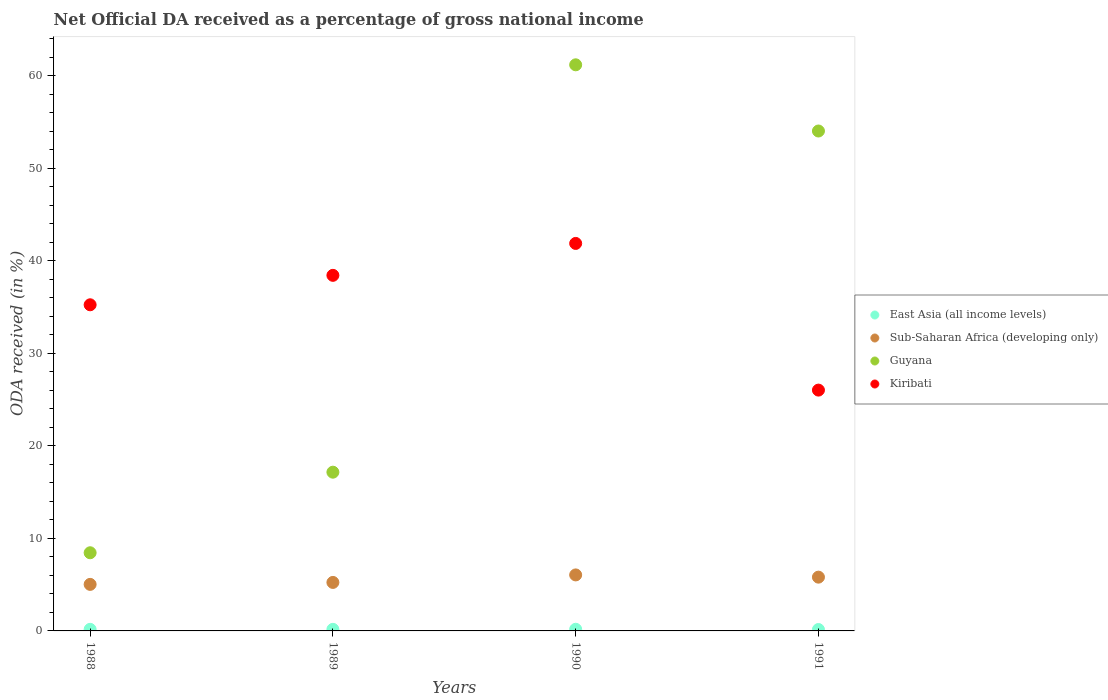Is the number of dotlines equal to the number of legend labels?
Make the answer very short. Yes. What is the net official DA received in Guyana in 1990?
Your answer should be compact. 61.17. Across all years, what is the maximum net official DA received in Guyana?
Your response must be concise. 61.17. Across all years, what is the minimum net official DA received in Kiribati?
Provide a short and direct response. 26.02. What is the total net official DA received in Guyana in the graph?
Your answer should be compact. 140.79. What is the difference between the net official DA received in Guyana in 1989 and that in 1990?
Provide a succinct answer. -44.02. What is the difference between the net official DA received in Guyana in 1991 and the net official DA received in Sub-Saharan Africa (developing only) in 1989?
Make the answer very short. 48.78. What is the average net official DA received in Guyana per year?
Give a very brief answer. 35.2. In the year 1989, what is the difference between the net official DA received in Sub-Saharan Africa (developing only) and net official DA received in Guyana?
Offer a very short reply. -11.91. What is the ratio of the net official DA received in Sub-Saharan Africa (developing only) in 1988 to that in 1991?
Keep it short and to the point. 0.87. Is the net official DA received in Guyana in 1989 less than that in 1991?
Your answer should be very brief. Yes. What is the difference between the highest and the second highest net official DA received in Sub-Saharan Africa (developing only)?
Your answer should be compact. 0.24. What is the difference between the highest and the lowest net official DA received in Kiribati?
Your answer should be very brief. 15.85. Is the sum of the net official DA received in Guyana in 1988 and 1991 greater than the maximum net official DA received in East Asia (all income levels) across all years?
Make the answer very short. Yes. Is it the case that in every year, the sum of the net official DA received in Sub-Saharan Africa (developing only) and net official DA received in Kiribati  is greater than the sum of net official DA received in East Asia (all income levels) and net official DA received in Guyana?
Make the answer very short. No. Is it the case that in every year, the sum of the net official DA received in Guyana and net official DA received in East Asia (all income levels)  is greater than the net official DA received in Sub-Saharan Africa (developing only)?
Provide a short and direct response. Yes. Is the net official DA received in East Asia (all income levels) strictly greater than the net official DA received in Sub-Saharan Africa (developing only) over the years?
Make the answer very short. No. Is the net official DA received in East Asia (all income levels) strictly less than the net official DA received in Guyana over the years?
Your response must be concise. Yes. How many years are there in the graph?
Your answer should be compact. 4. Does the graph contain grids?
Ensure brevity in your answer.  No. Where does the legend appear in the graph?
Provide a succinct answer. Center right. What is the title of the graph?
Offer a very short reply. Net Official DA received as a percentage of gross national income. What is the label or title of the X-axis?
Your response must be concise. Years. What is the label or title of the Y-axis?
Ensure brevity in your answer.  ODA received (in %). What is the ODA received (in %) in East Asia (all income levels) in 1988?
Your response must be concise. 0.17. What is the ODA received (in %) of Sub-Saharan Africa (developing only) in 1988?
Keep it short and to the point. 5.03. What is the ODA received (in %) in Guyana in 1988?
Make the answer very short. 8.45. What is the ODA received (in %) of Kiribati in 1988?
Offer a very short reply. 35.24. What is the ODA received (in %) of East Asia (all income levels) in 1989?
Give a very brief answer. 0.17. What is the ODA received (in %) in Sub-Saharan Africa (developing only) in 1989?
Your answer should be compact. 5.24. What is the ODA received (in %) of Guyana in 1989?
Offer a terse response. 17.15. What is the ODA received (in %) in Kiribati in 1989?
Give a very brief answer. 38.42. What is the ODA received (in %) in East Asia (all income levels) in 1990?
Offer a very short reply. 0.18. What is the ODA received (in %) in Sub-Saharan Africa (developing only) in 1990?
Provide a short and direct response. 6.05. What is the ODA received (in %) in Guyana in 1990?
Ensure brevity in your answer.  61.17. What is the ODA received (in %) of Kiribati in 1990?
Provide a succinct answer. 41.87. What is the ODA received (in %) in East Asia (all income levels) in 1991?
Your answer should be compact. 0.15. What is the ODA received (in %) of Sub-Saharan Africa (developing only) in 1991?
Provide a short and direct response. 5.81. What is the ODA received (in %) in Guyana in 1991?
Keep it short and to the point. 54.02. What is the ODA received (in %) in Kiribati in 1991?
Keep it short and to the point. 26.02. Across all years, what is the maximum ODA received (in %) in East Asia (all income levels)?
Give a very brief answer. 0.18. Across all years, what is the maximum ODA received (in %) in Sub-Saharan Africa (developing only)?
Provide a short and direct response. 6.05. Across all years, what is the maximum ODA received (in %) of Guyana?
Keep it short and to the point. 61.17. Across all years, what is the maximum ODA received (in %) in Kiribati?
Make the answer very short. 41.87. Across all years, what is the minimum ODA received (in %) in East Asia (all income levels)?
Give a very brief answer. 0.15. Across all years, what is the minimum ODA received (in %) in Sub-Saharan Africa (developing only)?
Your answer should be compact. 5.03. Across all years, what is the minimum ODA received (in %) of Guyana?
Give a very brief answer. 8.45. Across all years, what is the minimum ODA received (in %) in Kiribati?
Give a very brief answer. 26.02. What is the total ODA received (in %) of East Asia (all income levels) in the graph?
Ensure brevity in your answer.  0.67. What is the total ODA received (in %) in Sub-Saharan Africa (developing only) in the graph?
Offer a terse response. 22.13. What is the total ODA received (in %) of Guyana in the graph?
Make the answer very short. 140.79. What is the total ODA received (in %) in Kiribati in the graph?
Provide a short and direct response. 141.56. What is the difference between the ODA received (in %) in East Asia (all income levels) in 1988 and that in 1989?
Your answer should be compact. -0. What is the difference between the ODA received (in %) in Sub-Saharan Africa (developing only) in 1988 and that in 1989?
Offer a very short reply. -0.21. What is the difference between the ODA received (in %) in Guyana in 1988 and that in 1989?
Provide a short and direct response. -8.71. What is the difference between the ODA received (in %) of Kiribati in 1988 and that in 1989?
Provide a short and direct response. -3.18. What is the difference between the ODA received (in %) in East Asia (all income levels) in 1988 and that in 1990?
Your response must be concise. -0.01. What is the difference between the ODA received (in %) in Sub-Saharan Africa (developing only) in 1988 and that in 1990?
Provide a succinct answer. -1.02. What is the difference between the ODA received (in %) in Guyana in 1988 and that in 1990?
Your answer should be compact. -52.73. What is the difference between the ODA received (in %) of Kiribati in 1988 and that in 1990?
Ensure brevity in your answer.  -6.63. What is the difference between the ODA received (in %) in East Asia (all income levels) in 1988 and that in 1991?
Offer a terse response. 0.02. What is the difference between the ODA received (in %) of Sub-Saharan Africa (developing only) in 1988 and that in 1991?
Your answer should be very brief. -0.78. What is the difference between the ODA received (in %) of Guyana in 1988 and that in 1991?
Your response must be concise. -45.57. What is the difference between the ODA received (in %) in Kiribati in 1988 and that in 1991?
Your answer should be compact. 9.22. What is the difference between the ODA received (in %) of East Asia (all income levels) in 1989 and that in 1990?
Your response must be concise. -0.01. What is the difference between the ODA received (in %) of Sub-Saharan Africa (developing only) in 1989 and that in 1990?
Offer a terse response. -0.81. What is the difference between the ODA received (in %) of Guyana in 1989 and that in 1990?
Your response must be concise. -44.02. What is the difference between the ODA received (in %) in Kiribati in 1989 and that in 1990?
Offer a very short reply. -3.45. What is the difference between the ODA received (in %) in East Asia (all income levels) in 1989 and that in 1991?
Provide a short and direct response. 0.02. What is the difference between the ODA received (in %) in Sub-Saharan Africa (developing only) in 1989 and that in 1991?
Offer a very short reply. -0.57. What is the difference between the ODA received (in %) in Guyana in 1989 and that in 1991?
Keep it short and to the point. -36.87. What is the difference between the ODA received (in %) of Kiribati in 1989 and that in 1991?
Give a very brief answer. 12.4. What is the difference between the ODA received (in %) in East Asia (all income levels) in 1990 and that in 1991?
Ensure brevity in your answer.  0.03. What is the difference between the ODA received (in %) in Sub-Saharan Africa (developing only) in 1990 and that in 1991?
Give a very brief answer. 0.24. What is the difference between the ODA received (in %) in Guyana in 1990 and that in 1991?
Ensure brevity in your answer.  7.15. What is the difference between the ODA received (in %) in Kiribati in 1990 and that in 1991?
Provide a short and direct response. 15.85. What is the difference between the ODA received (in %) in East Asia (all income levels) in 1988 and the ODA received (in %) in Sub-Saharan Africa (developing only) in 1989?
Provide a short and direct response. -5.07. What is the difference between the ODA received (in %) in East Asia (all income levels) in 1988 and the ODA received (in %) in Guyana in 1989?
Ensure brevity in your answer.  -16.98. What is the difference between the ODA received (in %) in East Asia (all income levels) in 1988 and the ODA received (in %) in Kiribati in 1989?
Your response must be concise. -38.25. What is the difference between the ODA received (in %) in Sub-Saharan Africa (developing only) in 1988 and the ODA received (in %) in Guyana in 1989?
Ensure brevity in your answer.  -12.12. What is the difference between the ODA received (in %) of Sub-Saharan Africa (developing only) in 1988 and the ODA received (in %) of Kiribati in 1989?
Offer a terse response. -33.39. What is the difference between the ODA received (in %) in Guyana in 1988 and the ODA received (in %) in Kiribati in 1989?
Your answer should be very brief. -29.98. What is the difference between the ODA received (in %) of East Asia (all income levels) in 1988 and the ODA received (in %) of Sub-Saharan Africa (developing only) in 1990?
Provide a short and direct response. -5.88. What is the difference between the ODA received (in %) in East Asia (all income levels) in 1988 and the ODA received (in %) in Guyana in 1990?
Offer a very short reply. -61. What is the difference between the ODA received (in %) of East Asia (all income levels) in 1988 and the ODA received (in %) of Kiribati in 1990?
Provide a succinct answer. -41.7. What is the difference between the ODA received (in %) in Sub-Saharan Africa (developing only) in 1988 and the ODA received (in %) in Guyana in 1990?
Offer a terse response. -56.14. What is the difference between the ODA received (in %) in Sub-Saharan Africa (developing only) in 1988 and the ODA received (in %) in Kiribati in 1990?
Keep it short and to the point. -36.84. What is the difference between the ODA received (in %) of Guyana in 1988 and the ODA received (in %) of Kiribati in 1990?
Provide a succinct answer. -33.43. What is the difference between the ODA received (in %) of East Asia (all income levels) in 1988 and the ODA received (in %) of Sub-Saharan Africa (developing only) in 1991?
Give a very brief answer. -5.64. What is the difference between the ODA received (in %) of East Asia (all income levels) in 1988 and the ODA received (in %) of Guyana in 1991?
Give a very brief answer. -53.85. What is the difference between the ODA received (in %) of East Asia (all income levels) in 1988 and the ODA received (in %) of Kiribati in 1991?
Offer a very short reply. -25.85. What is the difference between the ODA received (in %) in Sub-Saharan Africa (developing only) in 1988 and the ODA received (in %) in Guyana in 1991?
Give a very brief answer. -48.99. What is the difference between the ODA received (in %) in Sub-Saharan Africa (developing only) in 1988 and the ODA received (in %) in Kiribati in 1991?
Provide a short and direct response. -20.99. What is the difference between the ODA received (in %) of Guyana in 1988 and the ODA received (in %) of Kiribati in 1991?
Your answer should be very brief. -17.58. What is the difference between the ODA received (in %) of East Asia (all income levels) in 1989 and the ODA received (in %) of Sub-Saharan Africa (developing only) in 1990?
Keep it short and to the point. -5.88. What is the difference between the ODA received (in %) in East Asia (all income levels) in 1989 and the ODA received (in %) in Guyana in 1990?
Ensure brevity in your answer.  -61. What is the difference between the ODA received (in %) in East Asia (all income levels) in 1989 and the ODA received (in %) in Kiribati in 1990?
Make the answer very short. -41.7. What is the difference between the ODA received (in %) in Sub-Saharan Africa (developing only) in 1989 and the ODA received (in %) in Guyana in 1990?
Offer a terse response. -55.93. What is the difference between the ODA received (in %) in Sub-Saharan Africa (developing only) in 1989 and the ODA received (in %) in Kiribati in 1990?
Keep it short and to the point. -36.63. What is the difference between the ODA received (in %) in Guyana in 1989 and the ODA received (in %) in Kiribati in 1990?
Offer a very short reply. -24.72. What is the difference between the ODA received (in %) in East Asia (all income levels) in 1989 and the ODA received (in %) in Sub-Saharan Africa (developing only) in 1991?
Offer a very short reply. -5.64. What is the difference between the ODA received (in %) of East Asia (all income levels) in 1989 and the ODA received (in %) of Guyana in 1991?
Keep it short and to the point. -53.85. What is the difference between the ODA received (in %) in East Asia (all income levels) in 1989 and the ODA received (in %) in Kiribati in 1991?
Keep it short and to the point. -25.85. What is the difference between the ODA received (in %) in Sub-Saharan Africa (developing only) in 1989 and the ODA received (in %) in Guyana in 1991?
Offer a terse response. -48.78. What is the difference between the ODA received (in %) in Sub-Saharan Africa (developing only) in 1989 and the ODA received (in %) in Kiribati in 1991?
Provide a short and direct response. -20.78. What is the difference between the ODA received (in %) in Guyana in 1989 and the ODA received (in %) in Kiribati in 1991?
Your response must be concise. -8.87. What is the difference between the ODA received (in %) of East Asia (all income levels) in 1990 and the ODA received (in %) of Sub-Saharan Africa (developing only) in 1991?
Provide a succinct answer. -5.63. What is the difference between the ODA received (in %) of East Asia (all income levels) in 1990 and the ODA received (in %) of Guyana in 1991?
Ensure brevity in your answer.  -53.84. What is the difference between the ODA received (in %) in East Asia (all income levels) in 1990 and the ODA received (in %) in Kiribati in 1991?
Provide a succinct answer. -25.84. What is the difference between the ODA received (in %) of Sub-Saharan Africa (developing only) in 1990 and the ODA received (in %) of Guyana in 1991?
Provide a succinct answer. -47.97. What is the difference between the ODA received (in %) of Sub-Saharan Africa (developing only) in 1990 and the ODA received (in %) of Kiribati in 1991?
Your answer should be very brief. -19.97. What is the difference between the ODA received (in %) of Guyana in 1990 and the ODA received (in %) of Kiribati in 1991?
Ensure brevity in your answer.  35.15. What is the average ODA received (in %) of East Asia (all income levels) per year?
Offer a terse response. 0.17. What is the average ODA received (in %) of Sub-Saharan Africa (developing only) per year?
Your response must be concise. 5.53. What is the average ODA received (in %) of Guyana per year?
Offer a very short reply. 35.2. What is the average ODA received (in %) of Kiribati per year?
Keep it short and to the point. 35.39. In the year 1988, what is the difference between the ODA received (in %) of East Asia (all income levels) and ODA received (in %) of Sub-Saharan Africa (developing only)?
Your answer should be very brief. -4.86. In the year 1988, what is the difference between the ODA received (in %) in East Asia (all income levels) and ODA received (in %) in Guyana?
Your answer should be compact. -8.28. In the year 1988, what is the difference between the ODA received (in %) in East Asia (all income levels) and ODA received (in %) in Kiribati?
Ensure brevity in your answer.  -35.07. In the year 1988, what is the difference between the ODA received (in %) of Sub-Saharan Africa (developing only) and ODA received (in %) of Guyana?
Give a very brief answer. -3.42. In the year 1988, what is the difference between the ODA received (in %) of Sub-Saharan Africa (developing only) and ODA received (in %) of Kiribati?
Give a very brief answer. -30.21. In the year 1988, what is the difference between the ODA received (in %) of Guyana and ODA received (in %) of Kiribati?
Make the answer very short. -26.8. In the year 1989, what is the difference between the ODA received (in %) in East Asia (all income levels) and ODA received (in %) in Sub-Saharan Africa (developing only)?
Make the answer very short. -5.07. In the year 1989, what is the difference between the ODA received (in %) of East Asia (all income levels) and ODA received (in %) of Guyana?
Offer a terse response. -16.98. In the year 1989, what is the difference between the ODA received (in %) of East Asia (all income levels) and ODA received (in %) of Kiribati?
Your answer should be compact. -38.25. In the year 1989, what is the difference between the ODA received (in %) in Sub-Saharan Africa (developing only) and ODA received (in %) in Guyana?
Your answer should be very brief. -11.91. In the year 1989, what is the difference between the ODA received (in %) in Sub-Saharan Africa (developing only) and ODA received (in %) in Kiribati?
Make the answer very short. -33.18. In the year 1989, what is the difference between the ODA received (in %) in Guyana and ODA received (in %) in Kiribati?
Your response must be concise. -21.27. In the year 1990, what is the difference between the ODA received (in %) in East Asia (all income levels) and ODA received (in %) in Sub-Saharan Africa (developing only)?
Provide a short and direct response. -5.87. In the year 1990, what is the difference between the ODA received (in %) in East Asia (all income levels) and ODA received (in %) in Guyana?
Provide a succinct answer. -60.99. In the year 1990, what is the difference between the ODA received (in %) in East Asia (all income levels) and ODA received (in %) in Kiribati?
Give a very brief answer. -41.69. In the year 1990, what is the difference between the ODA received (in %) in Sub-Saharan Africa (developing only) and ODA received (in %) in Guyana?
Make the answer very short. -55.12. In the year 1990, what is the difference between the ODA received (in %) of Sub-Saharan Africa (developing only) and ODA received (in %) of Kiribati?
Give a very brief answer. -35.82. In the year 1990, what is the difference between the ODA received (in %) in Guyana and ODA received (in %) in Kiribati?
Provide a succinct answer. 19.3. In the year 1991, what is the difference between the ODA received (in %) of East Asia (all income levels) and ODA received (in %) of Sub-Saharan Africa (developing only)?
Provide a succinct answer. -5.66. In the year 1991, what is the difference between the ODA received (in %) of East Asia (all income levels) and ODA received (in %) of Guyana?
Provide a short and direct response. -53.87. In the year 1991, what is the difference between the ODA received (in %) of East Asia (all income levels) and ODA received (in %) of Kiribati?
Provide a short and direct response. -25.87. In the year 1991, what is the difference between the ODA received (in %) of Sub-Saharan Africa (developing only) and ODA received (in %) of Guyana?
Provide a short and direct response. -48.21. In the year 1991, what is the difference between the ODA received (in %) in Sub-Saharan Africa (developing only) and ODA received (in %) in Kiribati?
Offer a very short reply. -20.21. In the year 1991, what is the difference between the ODA received (in %) in Guyana and ODA received (in %) in Kiribati?
Provide a short and direct response. 28. What is the ratio of the ODA received (in %) in East Asia (all income levels) in 1988 to that in 1989?
Provide a succinct answer. 1. What is the ratio of the ODA received (in %) of Sub-Saharan Africa (developing only) in 1988 to that in 1989?
Offer a terse response. 0.96. What is the ratio of the ODA received (in %) in Guyana in 1988 to that in 1989?
Give a very brief answer. 0.49. What is the ratio of the ODA received (in %) in Kiribati in 1988 to that in 1989?
Your answer should be compact. 0.92. What is the ratio of the ODA received (in %) of East Asia (all income levels) in 1988 to that in 1990?
Provide a short and direct response. 0.95. What is the ratio of the ODA received (in %) in Sub-Saharan Africa (developing only) in 1988 to that in 1990?
Offer a terse response. 0.83. What is the ratio of the ODA received (in %) of Guyana in 1988 to that in 1990?
Make the answer very short. 0.14. What is the ratio of the ODA received (in %) of Kiribati in 1988 to that in 1990?
Ensure brevity in your answer.  0.84. What is the ratio of the ODA received (in %) in East Asia (all income levels) in 1988 to that in 1991?
Provide a short and direct response. 1.11. What is the ratio of the ODA received (in %) of Sub-Saharan Africa (developing only) in 1988 to that in 1991?
Provide a succinct answer. 0.87. What is the ratio of the ODA received (in %) of Guyana in 1988 to that in 1991?
Offer a terse response. 0.16. What is the ratio of the ODA received (in %) of Kiribati in 1988 to that in 1991?
Give a very brief answer. 1.35. What is the ratio of the ODA received (in %) of East Asia (all income levels) in 1989 to that in 1990?
Keep it short and to the point. 0.95. What is the ratio of the ODA received (in %) of Sub-Saharan Africa (developing only) in 1989 to that in 1990?
Give a very brief answer. 0.87. What is the ratio of the ODA received (in %) in Guyana in 1989 to that in 1990?
Offer a very short reply. 0.28. What is the ratio of the ODA received (in %) in Kiribati in 1989 to that in 1990?
Give a very brief answer. 0.92. What is the ratio of the ODA received (in %) of East Asia (all income levels) in 1989 to that in 1991?
Provide a short and direct response. 1.12. What is the ratio of the ODA received (in %) of Sub-Saharan Africa (developing only) in 1989 to that in 1991?
Provide a succinct answer. 0.9. What is the ratio of the ODA received (in %) in Guyana in 1989 to that in 1991?
Provide a succinct answer. 0.32. What is the ratio of the ODA received (in %) in Kiribati in 1989 to that in 1991?
Provide a succinct answer. 1.48. What is the ratio of the ODA received (in %) of East Asia (all income levels) in 1990 to that in 1991?
Provide a succinct answer. 1.18. What is the ratio of the ODA received (in %) in Sub-Saharan Africa (developing only) in 1990 to that in 1991?
Your answer should be very brief. 1.04. What is the ratio of the ODA received (in %) in Guyana in 1990 to that in 1991?
Your answer should be very brief. 1.13. What is the ratio of the ODA received (in %) of Kiribati in 1990 to that in 1991?
Make the answer very short. 1.61. What is the difference between the highest and the second highest ODA received (in %) of East Asia (all income levels)?
Offer a very short reply. 0.01. What is the difference between the highest and the second highest ODA received (in %) in Sub-Saharan Africa (developing only)?
Ensure brevity in your answer.  0.24. What is the difference between the highest and the second highest ODA received (in %) in Guyana?
Ensure brevity in your answer.  7.15. What is the difference between the highest and the second highest ODA received (in %) of Kiribati?
Offer a terse response. 3.45. What is the difference between the highest and the lowest ODA received (in %) of East Asia (all income levels)?
Make the answer very short. 0.03. What is the difference between the highest and the lowest ODA received (in %) of Sub-Saharan Africa (developing only)?
Give a very brief answer. 1.02. What is the difference between the highest and the lowest ODA received (in %) of Guyana?
Ensure brevity in your answer.  52.73. What is the difference between the highest and the lowest ODA received (in %) of Kiribati?
Give a very brief answer. 15.85. 